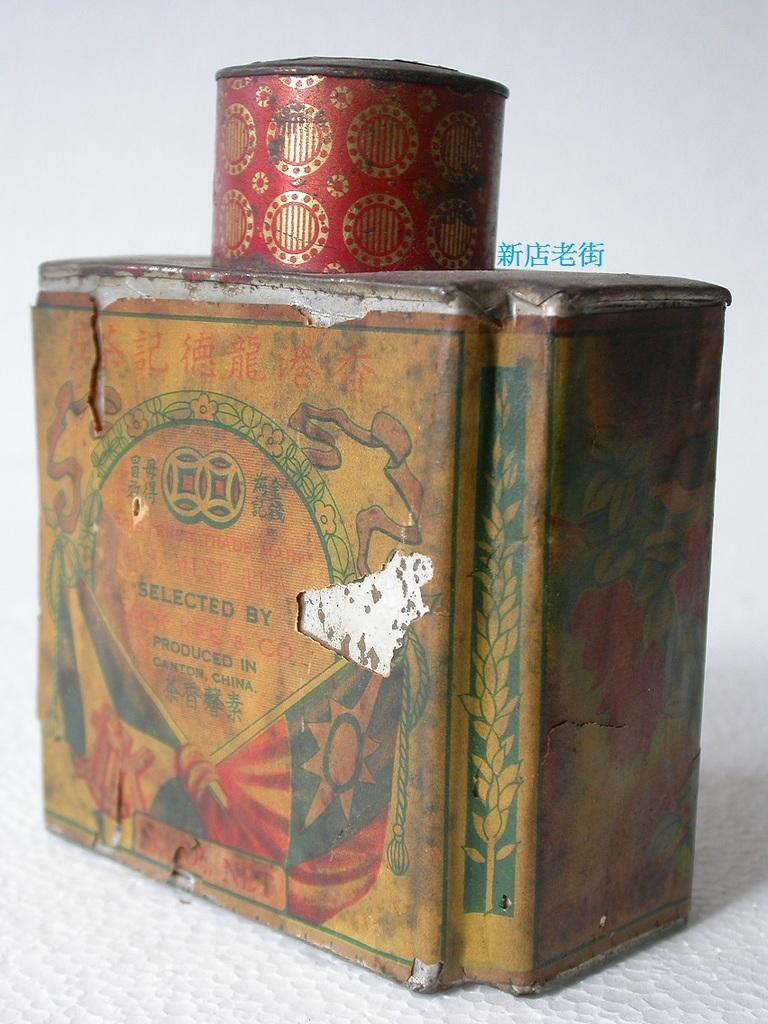<image>
Summarize the visual content of the image. Jasmine Tea once was inside the vintage Asian tin. 